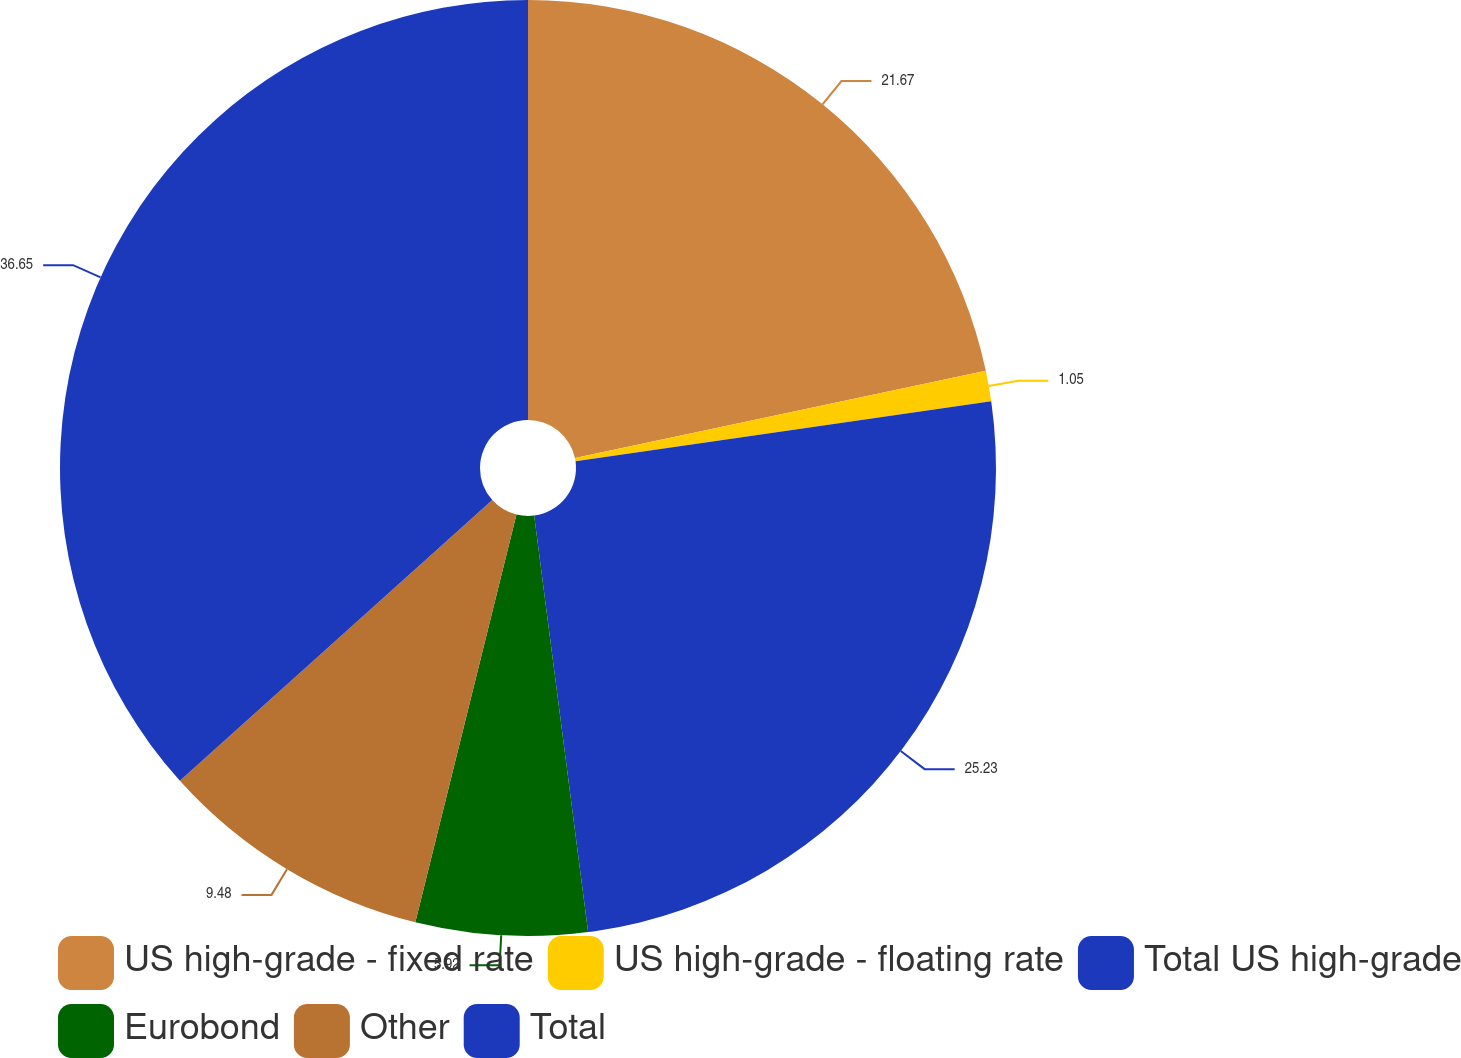<chart> <loc_0><loc_0><loc_500><loc_500><pie_chart><fcel>US high-grade - fixed rate<fcel>US high-grade - floating rate<fcel>Total US high-grade<fcel>Eurobond<fcel>Other<fcel>Total<nl><fcel>21.67%<fcel>1.05%<fcel>25.23%<fcel>5.92%<fcel>9.48%<fcel>36.65%<nl></chart> 